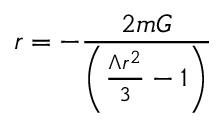<formula> <loc_0><loc_0><loc_500><loc_500>r = - \frac { 2 m G } { \left ( \frac { \Lambda r ^ { 2 } } { 3 } - 1 \right ) }</formula> 